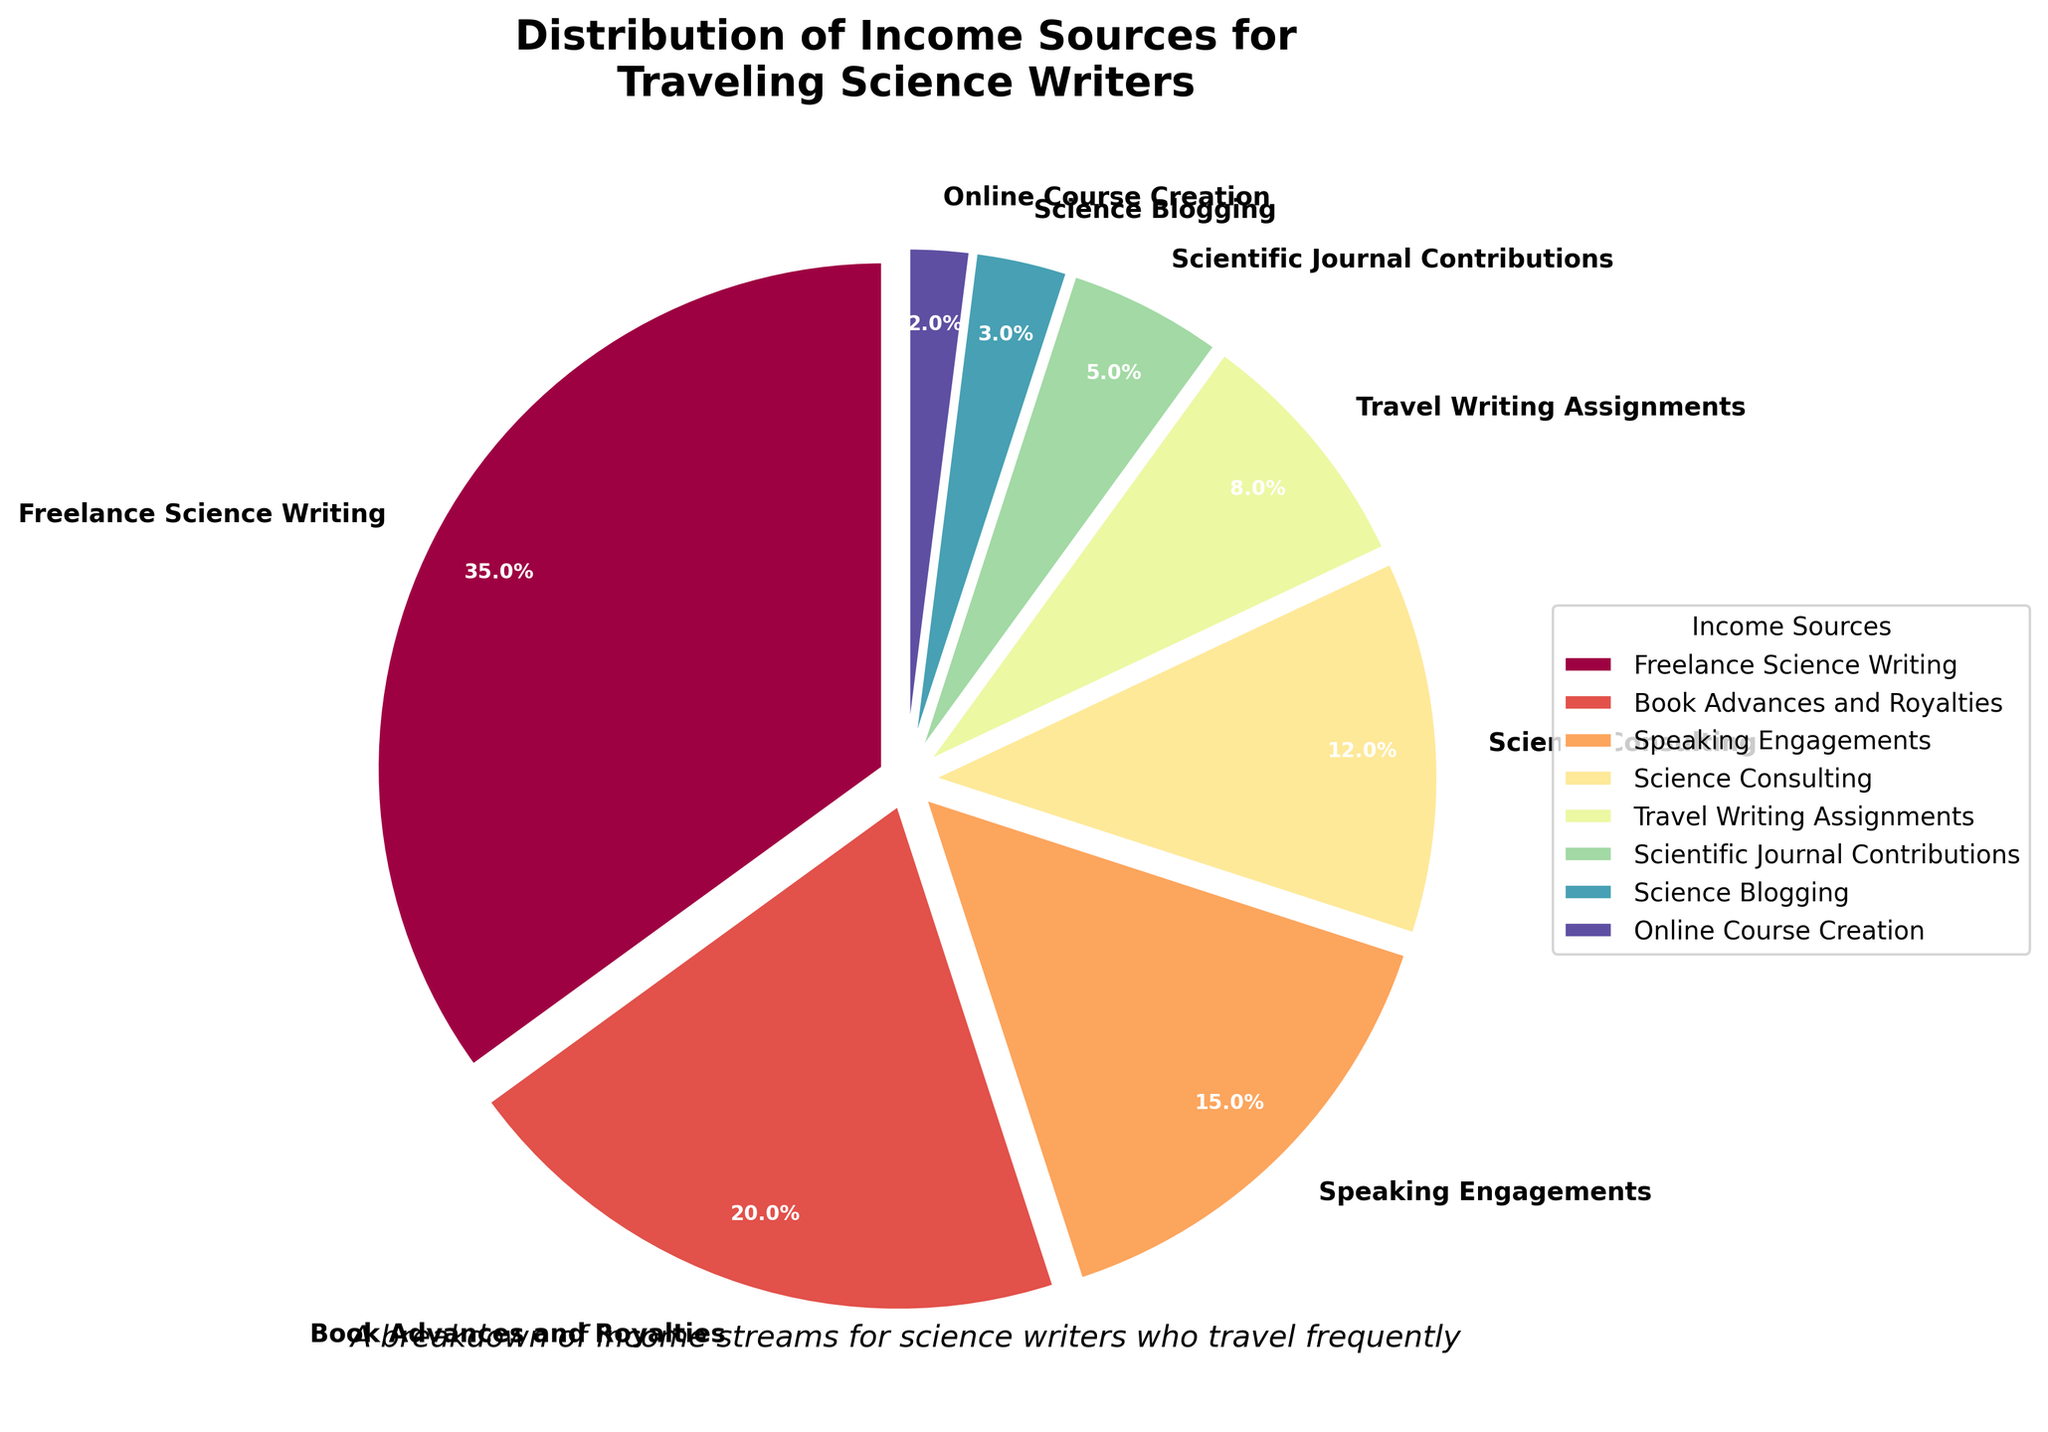What is the largest income source for traveling science writers? The pie chart shows various income sources for traveling science writers, with Freelance Science Writing having the largest slice, constituting 35%.
Answer: Freelance Science Writing (35%) What is the combined percentage of income from Book Advances and Royalties and Speaking Engagements? To find the combined percentage, sum the percentages of these two income sources: 20% (Book Advances and Royalties) + 15% (Speaking Engagements) = 35%.
Answer: 35% Which income source contributes the least, and what percentage does it represent? The smallest slice of the pie chart corresponds to Online Course Creation, representing 2% of the total income.
Answer: Online Course Creation (2%) By how much does Freelance Science Writing exceed Science Consulting in terms of percentage? Freelance Science Writing constitutes 35%, and Science Consulting constitutes 12%. The difference is 35% - 12% = 23%.
Answer: 23% What portion of the income sources is contributed by Scientific Journal Contributions and Science Blogging combined? Sum the percentages of Scientific Journal Contributions and Science Blogging: 5% + 3% = 8%.
Answer: 8% How does the percentage of income from Book Advances and Royalties compare to Science Consulting? Book Advances and Royalties make up 20%, while Science Consulting makes up 12%. Book Advances and Royalties have a higher percentage.
Answer: Book Advances and Royalties (20%) > Science Consulting (12%) What is the difference in income percentage between Speaking Engagements and Travel Writing Assignments? Speaking Engagements account for 15% while Travel Writing Assignments account for 8%. The difference is 15% - 8% = 7%.
Answer: 7% What are the three smallest income sources, and what is their combined percentage? The three smallest income sources are Online Course Creation (2%), Science Blogging (3%), and Scientific Journal Contributions (5%). Their combined percentage is 2% + 3% + 5% = 10%.
Answer: 10% What is the percentage difference between the highest and lowest income sources? The highest income source is Freelance Science Writing at 35% and the lowest is Online Course Creation at 2%. The difference is 35% - 2% = 33%.
Answer: 33% Which income sources contribute more than 10% to the total income? The pie chart shows that Freelance Science Writing (35%), Book Advances and Royalties (20%), Speaking Engagements (15%), and Science Consulting (12%) all contribute more than 10% to the total income.
Answer: Freelance Science Writing, Book Advances and Royalties, Speaking Engagements, Science Consulting 